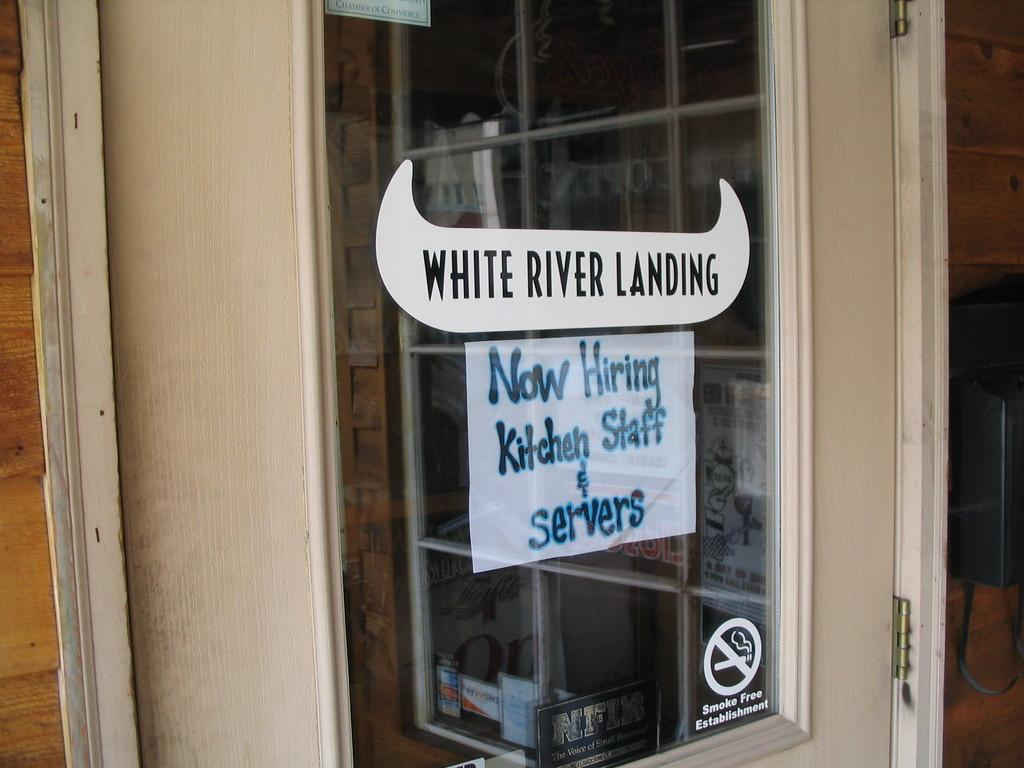What type of structure can be seen in the image? There is a wall in the image. What feature is present on the wall? There is a window in the image. What is placed on the window? Posters and stickers with text are visible on the window. Who is the expert in the image? There is no expert present in the image; it only features a wall, a window, posters, and stickers with text. What type of respect can be seen in the image? There is no indication of respect in the image; it only shows a wall, a window, posters, and stickers with text. 